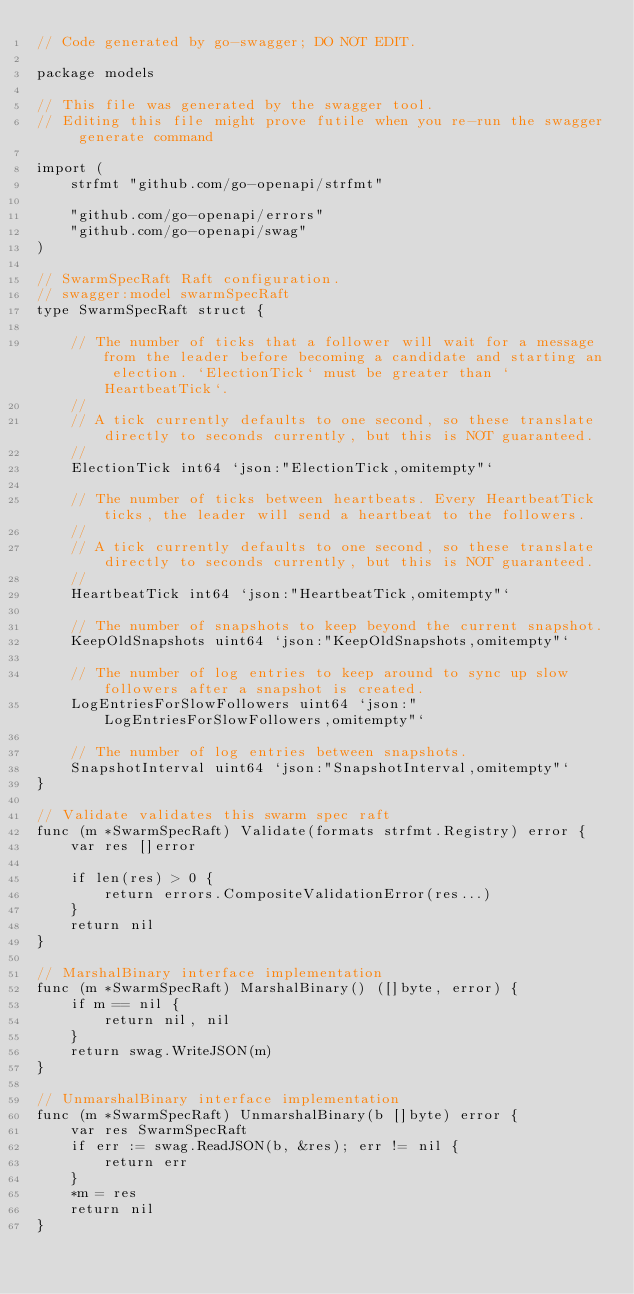Convert code to text. <code><loc_0><loc_0><loc_500><loc_500><_Go_>// Code generated by go-swagger; DO NOT EDIT.

package models

// This file was generated by the swagger tool.
// Editing this file might prove futile when you re-run the swagger generate command

import (
	strfmt "github.com/go-openapi/strfmt"

	"github.com/go-openapi/errors"
	"github.com/go-openapi/swag"
)

// SwarmSpecRaft Raft configuration.
// swagger:model swarmSpecRaft
type SwarmSpecRaft struct {

	// The number of ticks that a follower will wait for a message from the leader before becoming a candidate and starting an election. `ElectionTick` must be greater than `HeartbeatTick`.
	//
	// A tick currently defaults to one second, so these translate directly to seconds currently, but this is NOT guaranteed.
	//
	ElectionTick int64 `json:"ElectionTick,omitempty"`

	// The number of ticks between heartbeats. Every HeartbeatTick ticks, the leader will send a heartbeat to the followers.
	//
	// A tick currently defaults to one second, so these translate directly to seconds currently, but this is NOT guaranteed.
	//
	HeartbeatTick int64 `json:"HeartbeatTick,omitempty"`

	// The number of snapshots to keep beyond the current snapshot.
	KeepOldSnapshots uint64 `json:"KeepOldSnapshots,omitempty"`

	// The number of log entries to keep around to sync up slow followers after a snapshot is created.
	LogEntriesForSlowFollowers uint64 `json:"LogEntriesForSlowFollowers,omitempty"`

	// The number of log entries between snapshots.
	SnapshotInterval uint64 `json:"SnapshotInterval,omitempty"`
}

// Validate validates this swarm spec raft
func (m *SwarmSpecRaft) Validate(formats strfmt.Registry) error {
	var res []error

	if len(res) > 0 {
		return errors.CompositeValidationError(res...)
	}
	return nil
}

// MarshalBinary interface implementation
func (m *SwarmSpecRaft) MarshalBinary() ([]byte, error) {
	if m == nil {
		return nil, nil
	}
	return swag.WriteJSON(m)
}

// UnmarshalBinary interface implementation
func (m *SwarmSpecRaft) UnmarshalBinary(b []byte) error {
	var res SwarmSpecRaft
	if err := swag.ReadJSON(b, &res); err != nil {
		return err
	}
	*m = res
	return nil
}
</code> 